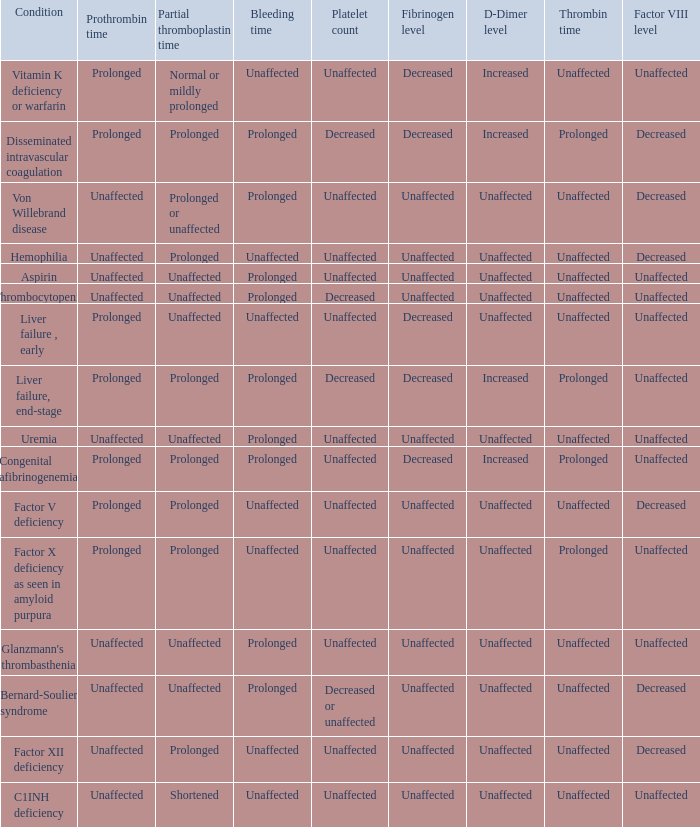Which Bleeding time has a Condition of factor x deficiency as seen in amyloid purpura? Unaffected. 